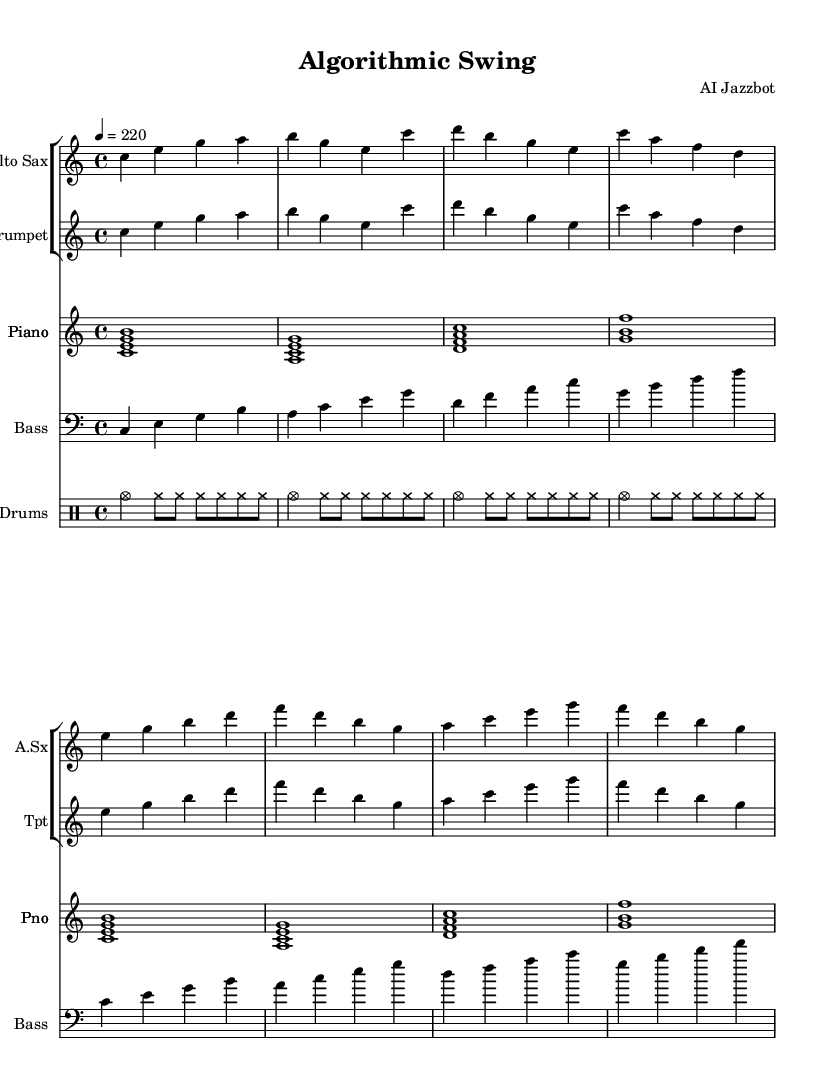What is the key signature of this music? The key signature of the piece is indicated in the global section. It shows the key of C major, which has no sharps or flats.
Answer: C major What is the time signature of this music? The time signature is found in the global section as well, indicating a 4/4 time signature, meaning there are four beats per measure and the quarter note receives one beat.
Answer: 4/4 What is the tempo marking of this music? The tempo is specified in the global section with the marking "4 = 220", which means there are 220 beats per minute when counting quarter notes.
Answer: 220 What instruments are featured in this composition? The instruments are listed at the beginning of each staff. The score includes Alto Sax, Trumpet, Piano, Bass, and Drums.
Answer: Alto Sax, Trumpet, Piano, Bass, Drums What type of bass line is used in this piece? The bass line is written in a walking style, which typically involves quarter notes and moves smoothly through chord tones, commonly used in jazz standards.
Answer: Walking bass line How many bars does the main theme last? The main theme can be identified as the first 8 bars for both the Alto Sax and Trumpet, which repeat in the score.
Answer: 8 bars What kind of rhythmic pattern is used in the drums? The drum pattern is described in the drummode section and consists of a bebop pattern that includes cymbals played in a specific rhythmic sequence with a consistent groove.
Answer: Bebop pattern 